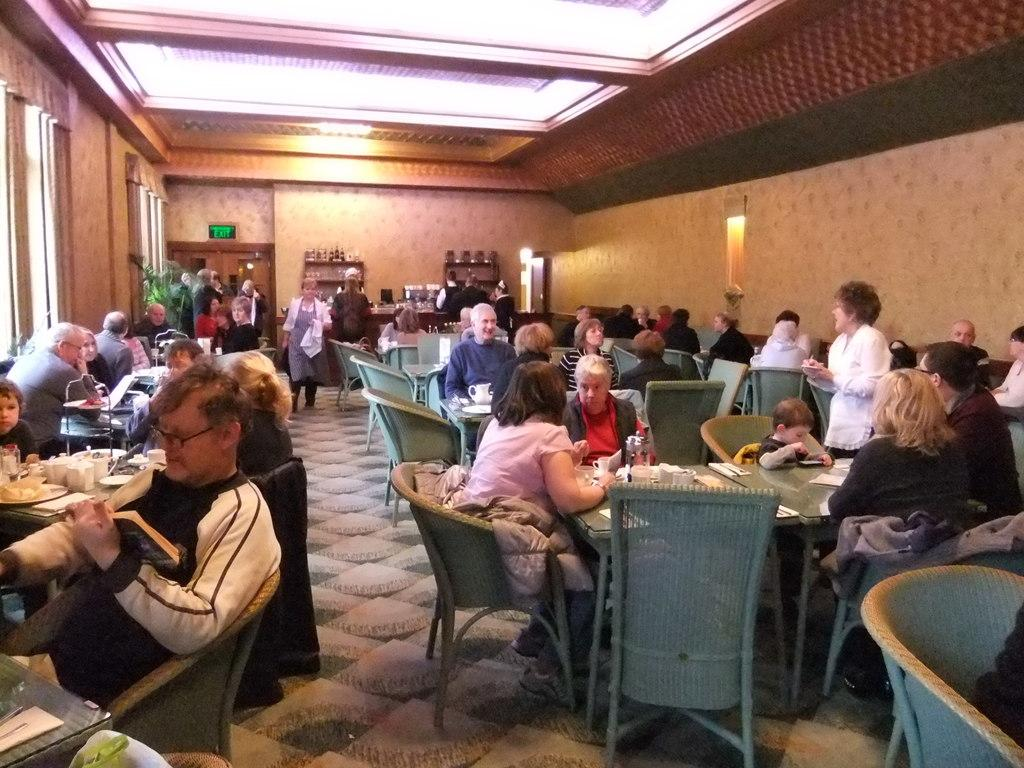What type of establishment is shown in the image? The image depicts a restaurant. What are the people in the image doing? The people in the image are seated on chairs. What items can be seen on the table in the image? There are cups and plates on a table in the image. Can you describe the woman in the image? There is a woman standing in the image. What type of plant is growing in the water near the woman in the image? There is no water or plant visible in the image; it depicts a restaurant with people seated at tables. 